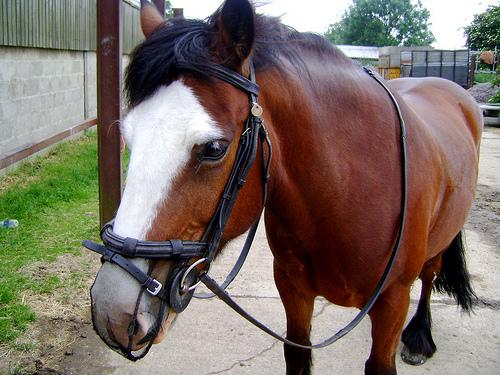Are there any trees or buildings visible in the image? If so, describe their appearance. No, there are no trees or buildings visible in the image. The background primarily shows a stable or barn structure. Count the number of horse-related objects mentioned in the image. There is only one horse-related object mentioned, which is the horse itself. What is the primary object in this image, and what is it doing? The primary object in this image is a brown horse with a white stripe on its face, standing in a stable area. Assess the emotions or feelings conveyed by the horse in the image. The horse appears calm and attentive, standing still with a relaxed posture. Identify two items related to the horse's bridle and describe their colors. The bridle is black, and it features a silver-colored buckle and bit. Describe one complex reasoning task that could be completed using the information from this image. One could analyze the horse's breed and characteristics based on its physical features and markings visible in the image. List two prominent features of the horse's head in the image. The horse has a white stripe on its face and dark, alert eyes. Analyze the interaction between the horse and its surroundings. The horse is standing calmly in a stable environment, suggesting it is accustomed to and comfortable in this setting. Evaluate the overall quality and clarity of the image. The image is of good quality and clarity, with the horse and its features clearly visible and well-focused. Mention an object that is located on the ground and describe its appearance. There is no object visible on the ground in the image. 